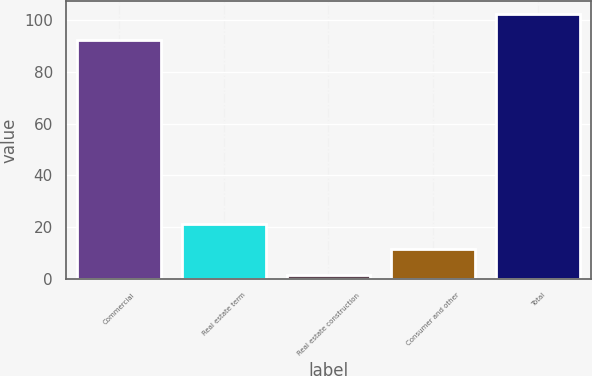Convert chart to OTSL. <chart><loc_0><loc_0><loc_500><loc_500><bar_chart><fcel>Commercial<fcel>Real estate term<fcel>Real estate construction<fcel>Consumer and other<fcel>Total<nl><fcel>92.3<fcel>21.2<fcel>1.5<fcel>11.35<fcel>102.15<nl></chart> 